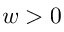<formula> <loc_0><loc_0><loc_500><loc_500>w > 0</formula> 